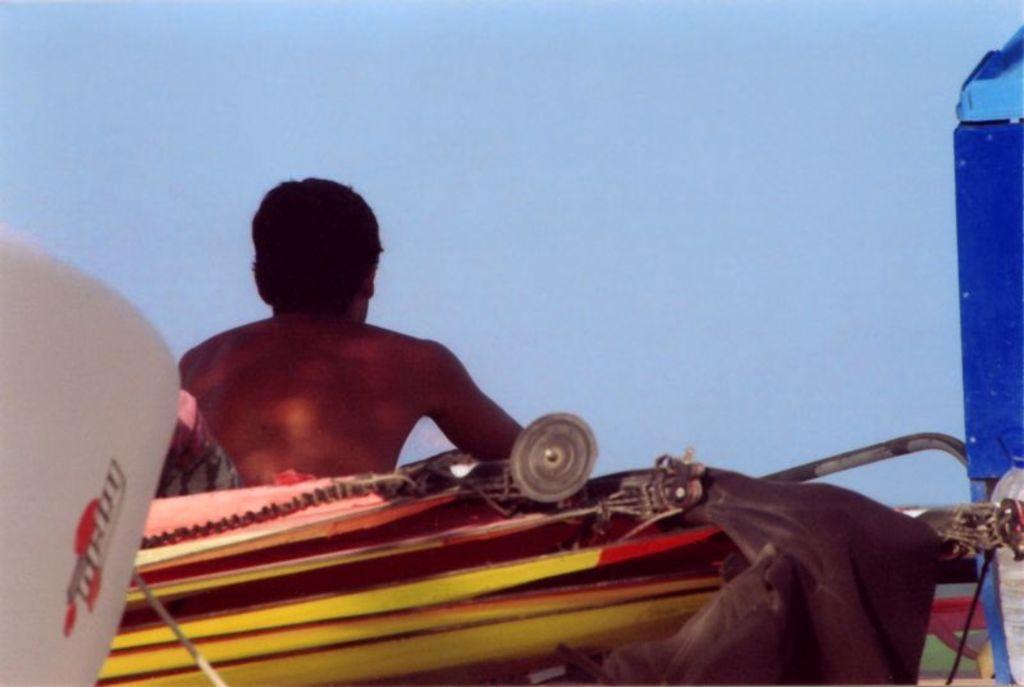In one or two sentences, can you explain what this image depicts? In this image we can see a person sitting and sky in the background. 